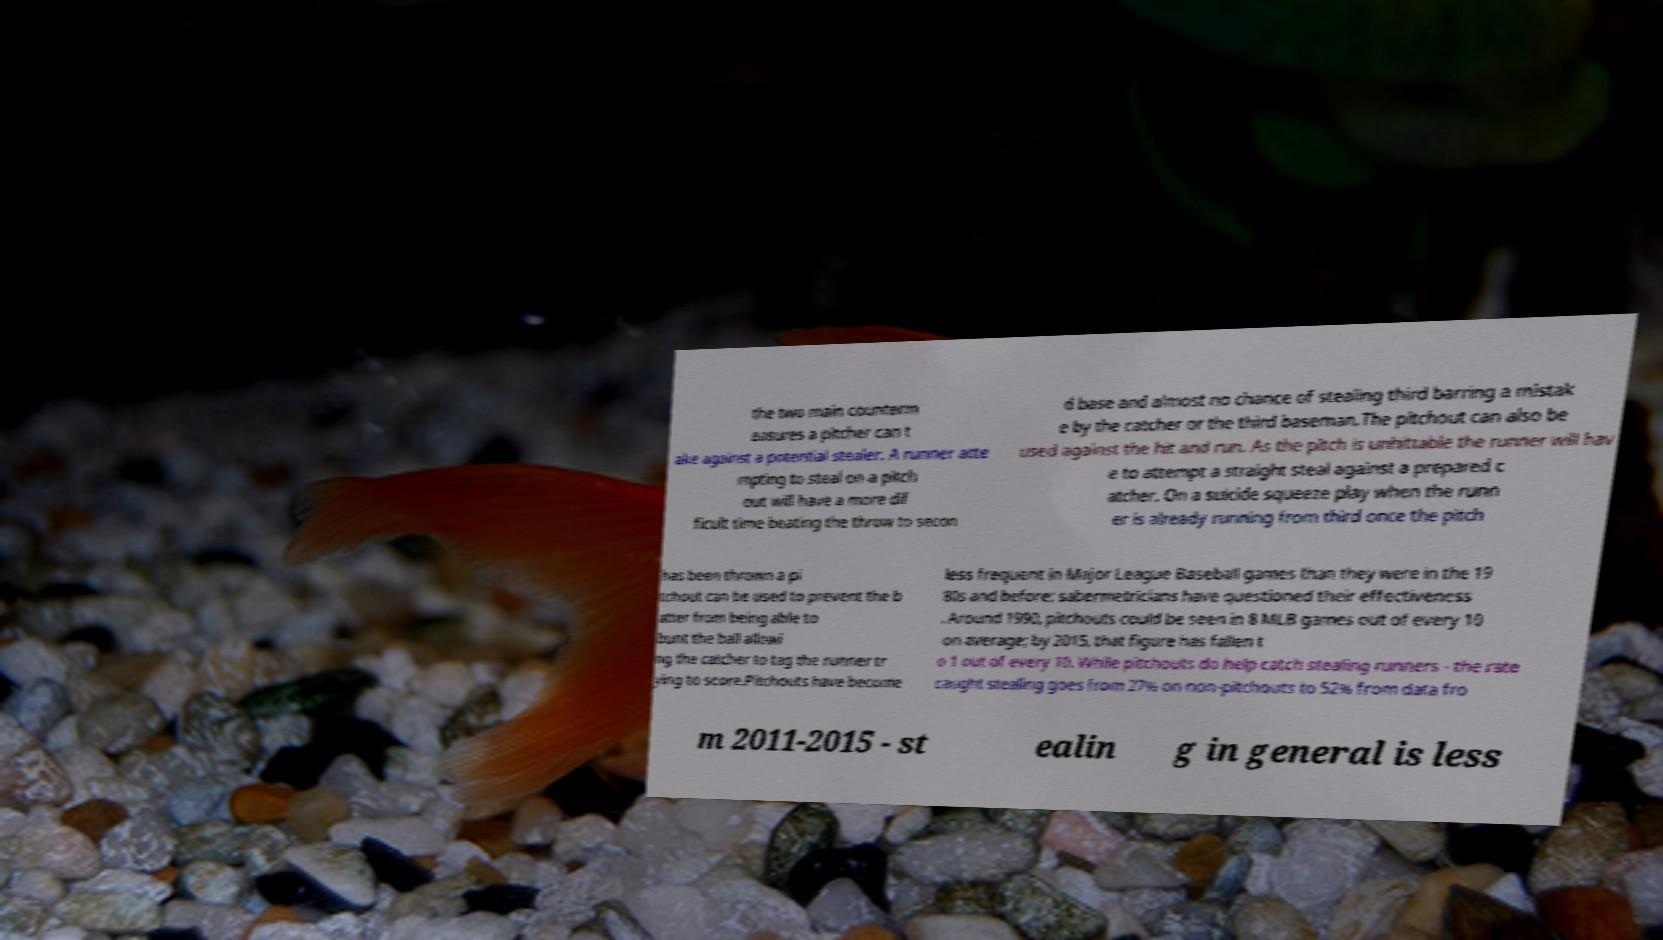I need the written content from this picture converted into text. Can you do that? the two main counterm easures a pitcher can t ake against a potential stealer. A runner atte mpting to steal on a pitch out will have a more dif ficult time beating the throw to secon d base and almost no chance of stealing third barring a mistak e by the catcher or the third baseman.The pitchout can also be used against the hit and run. As the pitch is unhittable the runner will hav e to attempt a straight steal against a prepared c atcher. On a suicide squeeze play when the runn er is already running from third once the pitch has been thrown a pi tchout can be used to prevent the b atter from being able to bunt the ball allowi ng the catcher to tag the runner tr ying to score.Pitchouts have become less frequent in Major League Baseball games than they were in the 19 80s and before; sabermetricians have questioned their effectiveness . Around 1990, pitchouts could be seen in 8 MLB games out of every 10 on average; by 2015, that figure has fallen t o 1 out of every 10. While pitchouts do help catch stealing runners - the rate caught stealing goes from 27% on non-pitchouts to 52% from data fro m 2011-2015 - st ealin g in general is less 